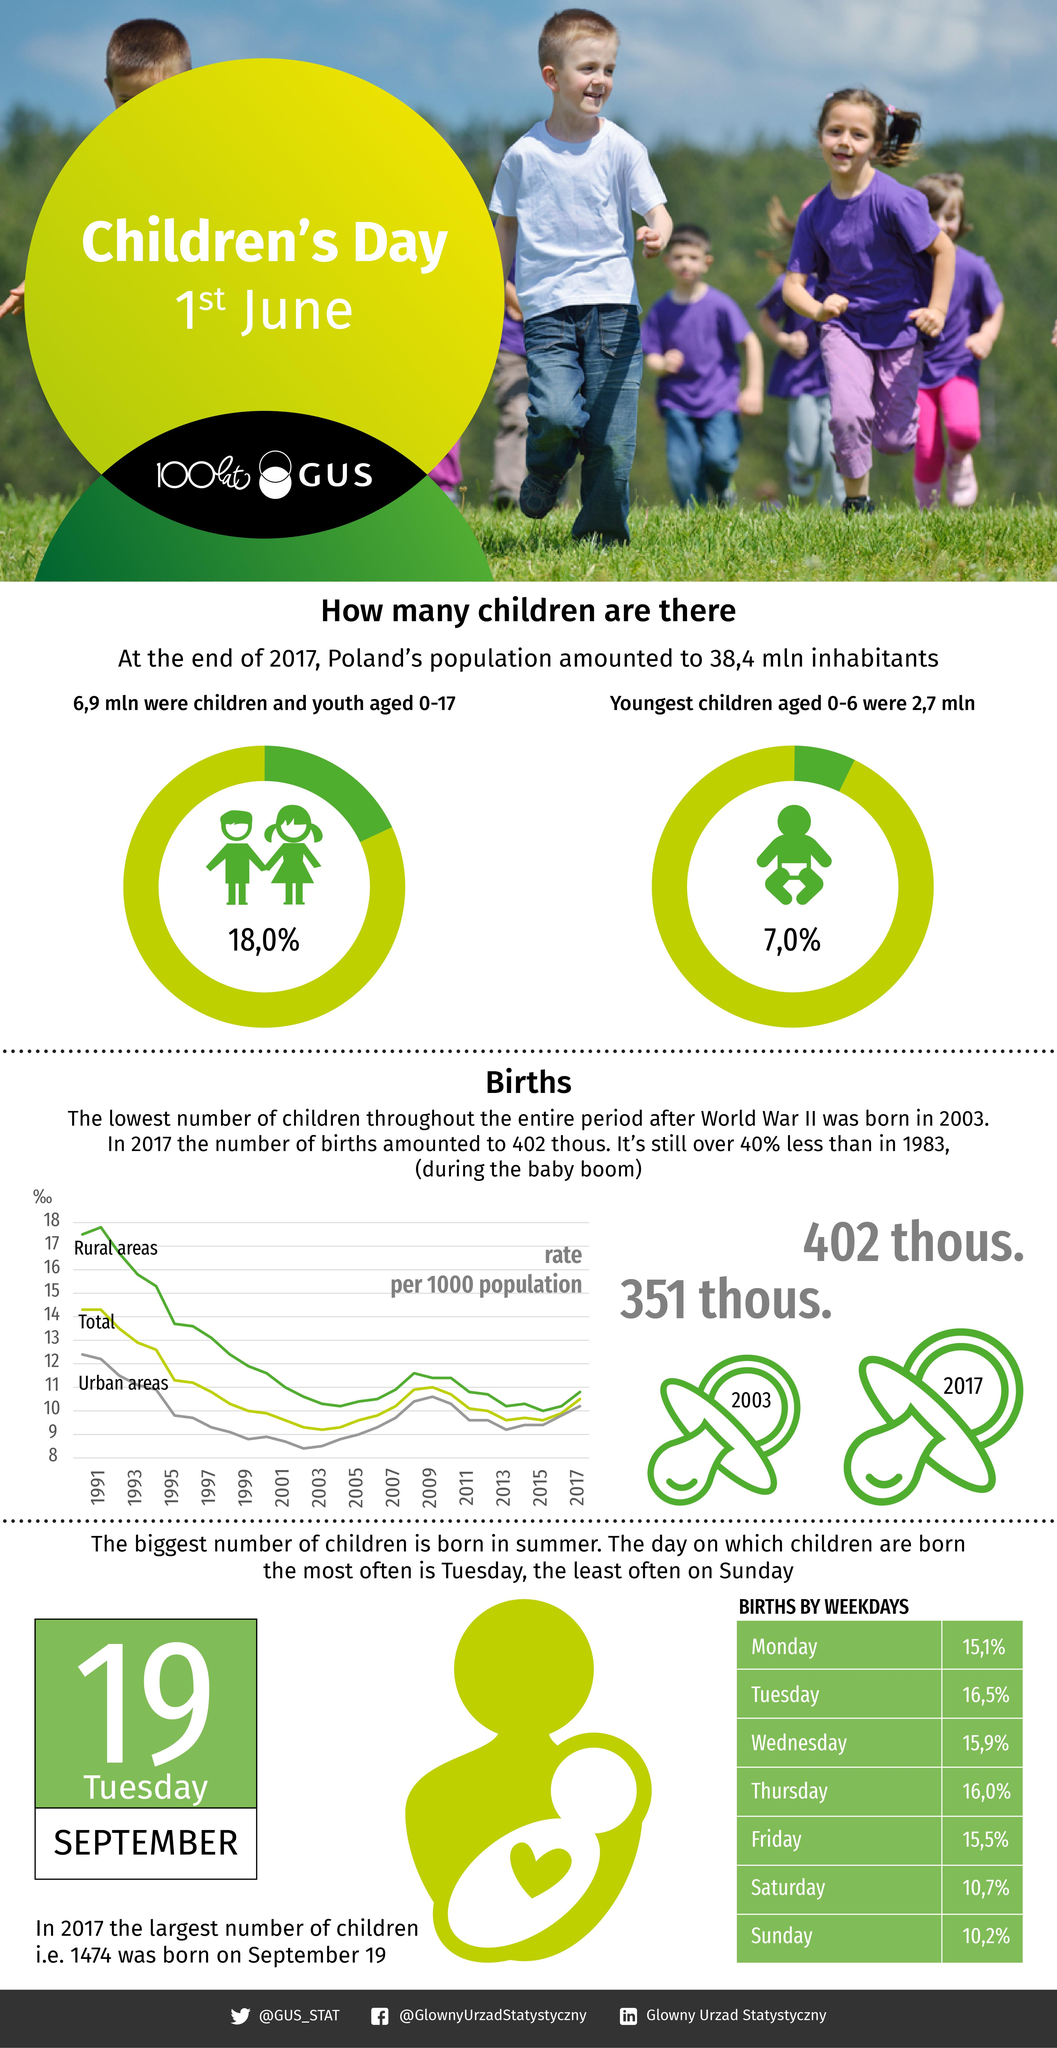Mention a couple of crucial points in this snapshot. Births occurred least frequently on Saturdays and Sundays. The Twitter handle "@GUS\_STAT..." has been mentioned. The Facebook account mentioned is "@GlownyUrzadStatystyczny". In 2017, there were 402 thousand births. In 1991, the urban areas had the highest birth rate per 1000 population. 